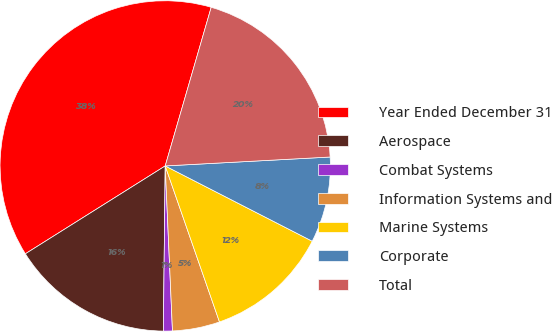Convert chart. <chart><loc_0><loc_0><loc_500><loc_500><pie_chart><fcel>Year Ended December 31<fcel>Aerospace<fcel>Combat Systems<fcel>Information Systems and<fcel>Marine Systems<fcel>Corporate<fcel>Total<nl><fcel>38.42%<fcel>15.89%<fcel>0.88%<fcel>4.63%<fcel>12.14%<fcel>8.39%<fcel>19.65%<nl></chart> 